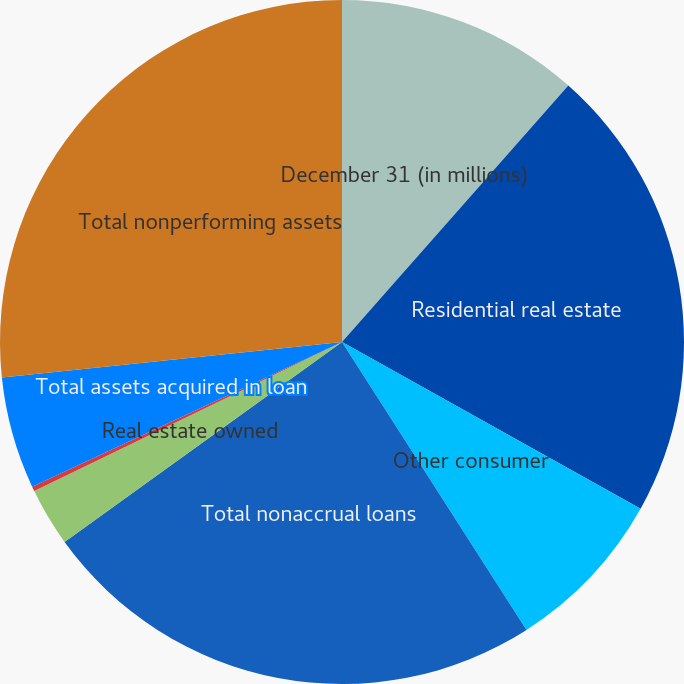Convert chart to OTSL. <chart><loc_0><loc_0><loc_500><loc_500><pie_chart><fcel>December 31 (in millions)<fcel>Residential real estate<fcel>Other consumer<fcel>Total nonaccrual loans<fcel>Real estate owned<fcel>Other<fcel>Total assets acquired in loan<fcel>Total nonperforming assets<nl><fcel>11.51%<fcel>21.6%<fcel>7.82%<fcel>24.13%<fcel>2.76%<fcel>0.23%<fcel>5.29%<fcel>26.66%<nl></chart> 